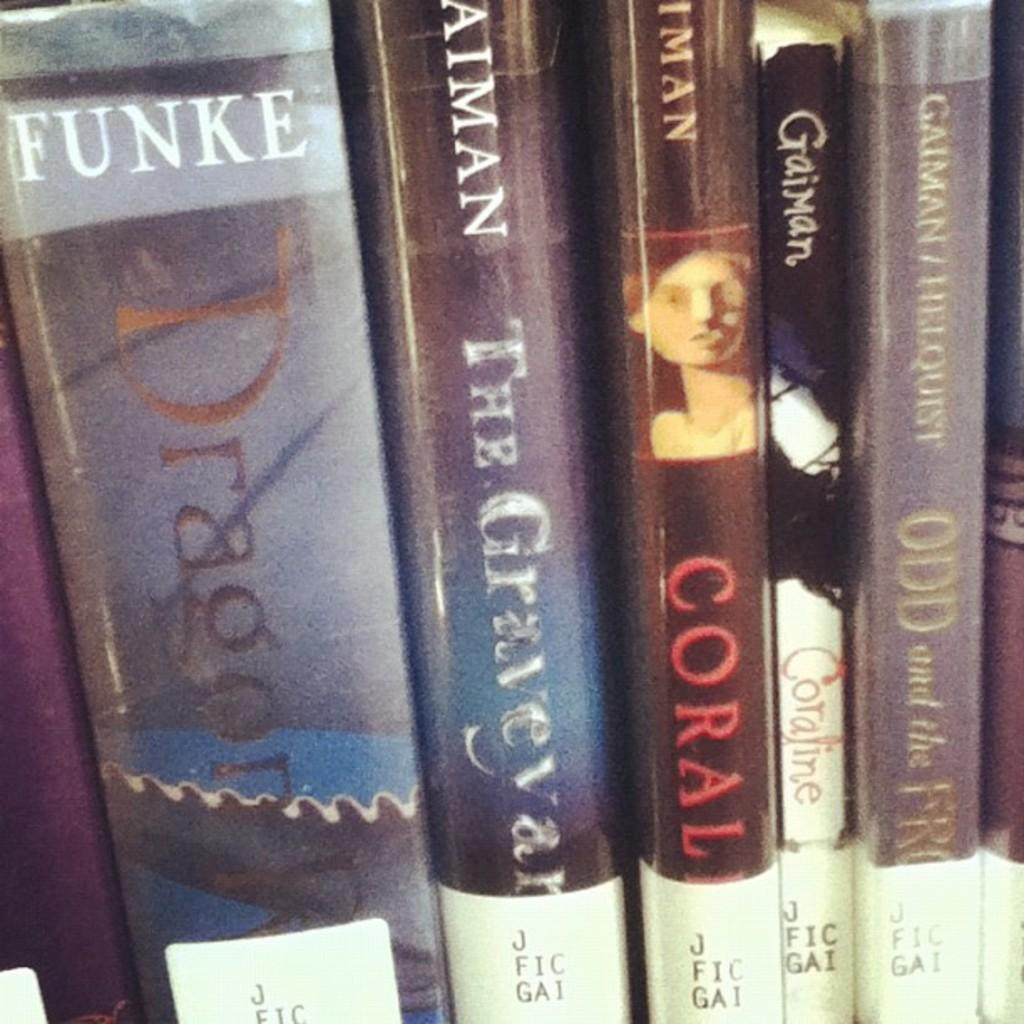<image>
Share a concise interpretation of the image provided. Many books at the library, the largest is called Dragon 